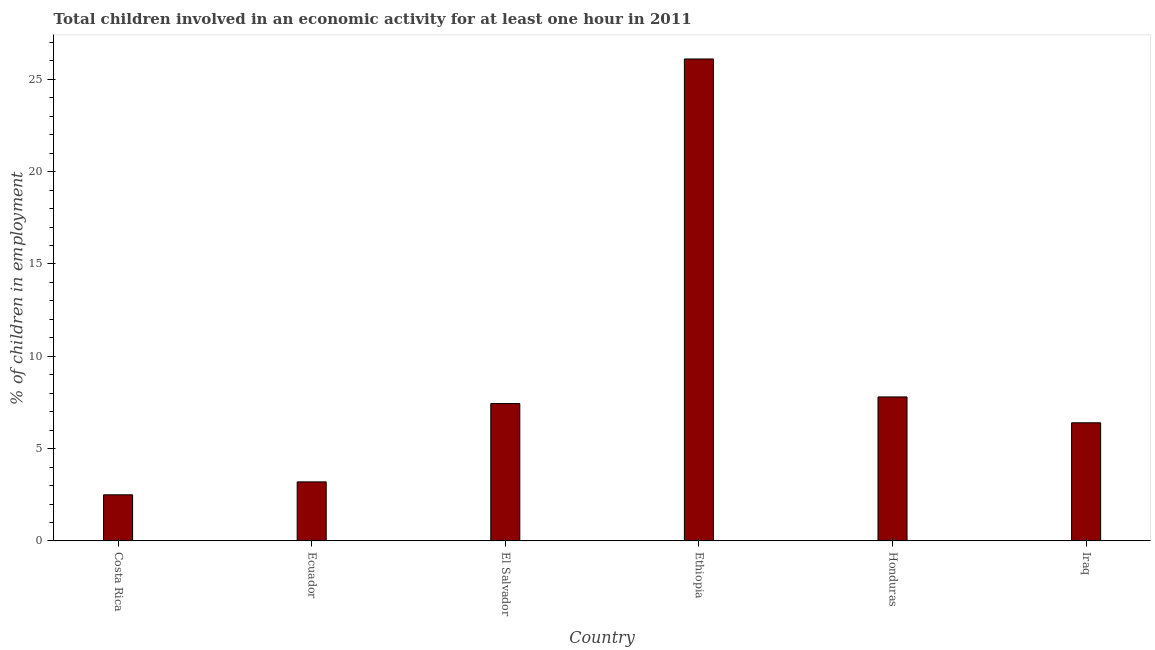What is the title of the graph?
Make the answer very short. Total children involved in an economic activity for at least one hour in 2011. What is the label or title of the X-axis?
Provide a short and direct response. Country. What is the label or title of the Y-axis?
Make the answer very short. % of children in employment. Across all countries, what is the maximum percentage of children in employment?
Provide a succinct answer. 26.1. In which country was the percentage of children in employment maximum?
Ensure brevity in your answer.  Ethiopia. What is the sum of the percentage of children in employment?
Ensure brevity in your answer.  53.44. What is the difference between the percentage of children in employment in El Salvador and Iraq?
Offer a terse response. 1.04. What is the average percentage of children in employment per country?
Ensure brevity in your answer.  8.91. What is the median percentage of children in employment?
Your answer should be very brief. 6.92. In how many countries, is the percentage of children in employment greater than 14 %?
Your response must be concise. 1. What is the ratio of the percentage of children in employment in Ethiopia to that in Iraq?
Your answer should be very brief. 4.08. What is the difference between the highest and the lowest percentage of children in employment?
Your answer should be compact. 23.6. In how many countries, is the percentage of children in employment greater than the average percentage of children in employment taken over all countries?
Ensure brevity in your answer.  1. How many bars are there?
Make the answer very short. 6. How many countries are there in the graph?
Offer a very short reply. 6. What is the % of children in employment of El Salvador?
Offer a terse response. 7.44. What is the % of children in employment of Ethiopia?
Offer a terse response. 26.1. What is the difference between the % of children in employment in Costa Rica and Ecuador?
Provide a succinct answer. -0.7. What is the difference between the % of children in employment in Costa Rica and El Salvador?
Your answer should be very brief. -4.94. What is the difference between the % of children in employment in Costa Rica and Ethiopia?
Provide a short and direct response. -23.6. What is the difference between the % of children in employment in Ecuador and El Salvador?
Give a very brief answer. -4.24. What is the difference between the % of children in employment in Ecuador and Ethiopia?
Give a very brief answer. -22.9. What is the difference between the % of children in employment in El Salvador and Ethiopia?
Ensure brevity in your answer.  -18.66. What is the difference between the % of children in employment in El Salvador and Honduras?
Offer a terse response. -0.36. What is the difference between the % of children in employment in El Salvador and Iraq?
Keep it short and to the point. 1.04. What is the difference between the % of children in employment in Ethiopia and Honduras?
Offer a very short reply. 18.3. What is the difference between the % of children in employment in Ethiopia and Iraq?
Give a very brief answer. 19.7. What is the ratio of the % of children in employment in Costa Rica to that in Ecuador?
Provide a short and direct response. 0.78. What is the ratio of the % of children in employment in Costa Rica to that in El Salvador?
Your answer should be compact. 0.34. What is the ratio of the % of children in employment in Costa Rica to that in Ethiopia?
Keep it short and to the point. 0.1. What is the ratio of the % of children in employment in Costa Rica to that in Honduras?
Provide a short and direct response. 0.32. What is the ratio of the % of children in employment in Costa Rica to that in Iraq?
Your answer should be compact. 0.39. What is the ratio of the % of children in employment in Ecuador to that in El Salvador?
Ensure brevity in your answer.  0.43. What is the ratio of the % of children in employment in Ecuador to that in Ethiopia?
Give a very brief answer. 0.12. What is the ratio of the % of children in employment in Ecuador to that in Honduras?
Ensure brevity in your answer.  0.41. What is the ratio of the % of children in employment in Ecuador to that in Iraq?
Your answer should be compact. 0.5. What is the ratio of the % of children in employment in El Salvador to that in Ethiopia?
Keep it short and to the point. 0.28. What is the ratio of the % of children in employment in El Salvador to that in Honduras?
Provide a short and direct response. 0.95. What is the ratio of the % of children in employment in El Salvador to that in Iraq?
Ensure brevity in your answer.  1.16. What is the ratio of the % of children in employment in Ethiopia to that in Honduras?
Offer a terse response. 3.35. What is the ratio of the % of children in employment in Ethiopia to that in Iraq?
Keep it short and to the point. 4.08. What is the ratio of the % of children in employment in Honduras to that in Iraq?
Offer a terse response. 1.22. 